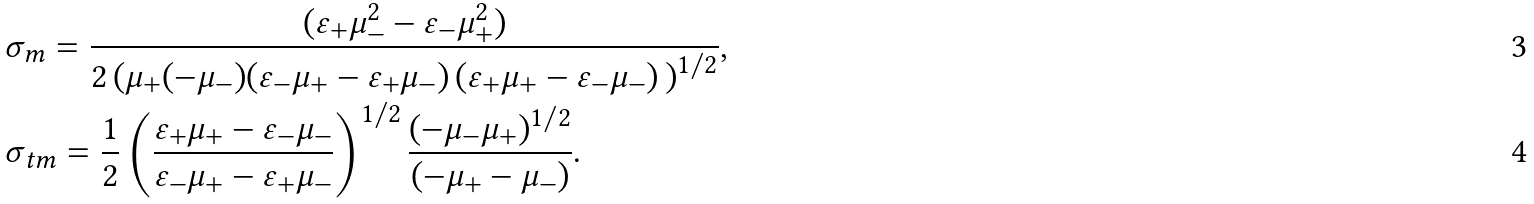<formula> <loc_0><loc_0><loc_500><loc_500>& \sigma _ { m } = \frac { ( \varepsilon _ { + } \mu _ { - } ^ { 2 } - \varepsilon _ { - } \mu _ { + } ^ { 2 } ) } { 2 \left ( \mu _ { + } ( - \mu _ { - } ) ( { \varepsilon _ { - } } { \mu _ { + } } - { \varepsilon _ { + } } { \mu _ { - } } ) \, ( \varepsilon _ { + } \mu _ { + } - \varepsilon _ { - } \mu _ { - } ) \, \right ) ^ { 1 / 2 } } , \\ & \sigma _ { t m } = \frac { 1 } { 2 } \left ( \frac { \varepsilon _ { + } \mu _ { + } - \varepsilon _ { - } \mu _ { - } } { \varepsilon _ { - } \mu _ { + } - \varepsilon _ { + } \mu _ { - } } \right ) ^ { 1 / 2 } \frac { ( - \mu _ { - } \mu _ { + } ) ^ { 1 / 2 } } { ( - \mu _ { + } - \mu _ { - } ) } .</formula> 